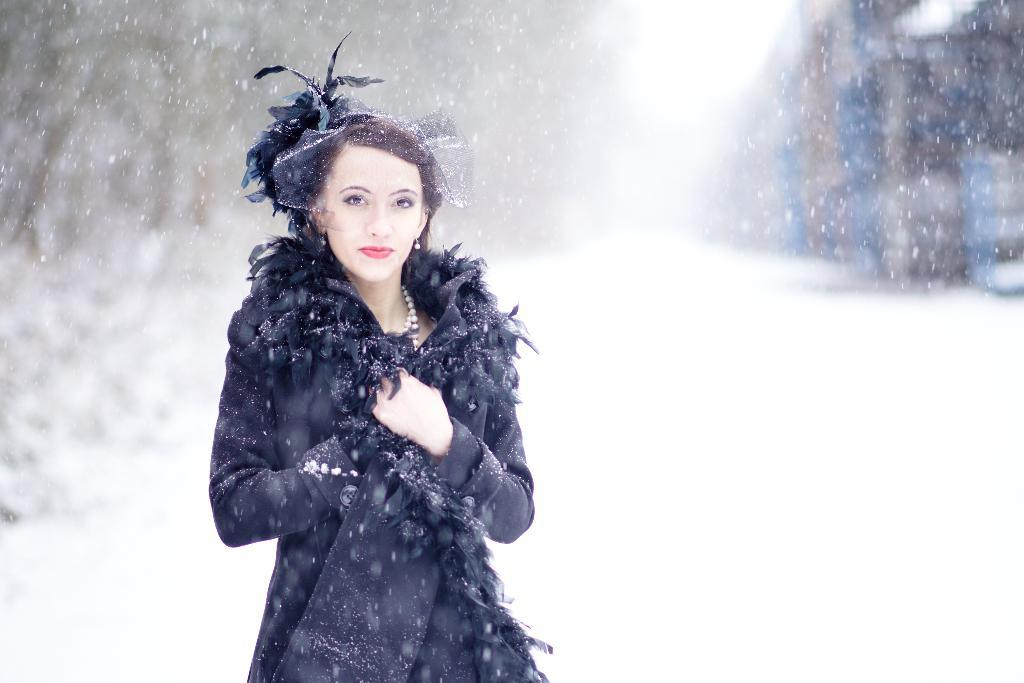Who is present in the image? There is a woman in the image. Where is the woman positioned in the image? The woman is standing on the left side. What is the woman wearing? The woman is wearing a black dress and a pearl necklace. What can be observed about the woman's hair? The woman has hair on her head. What is the weather condition in the image? There is snowfall in the image. How would you describe the background of the image? The background of the image is blurred. Can you see a doll kicking a ball in the image? No, there is no doll or ball present in the image. 